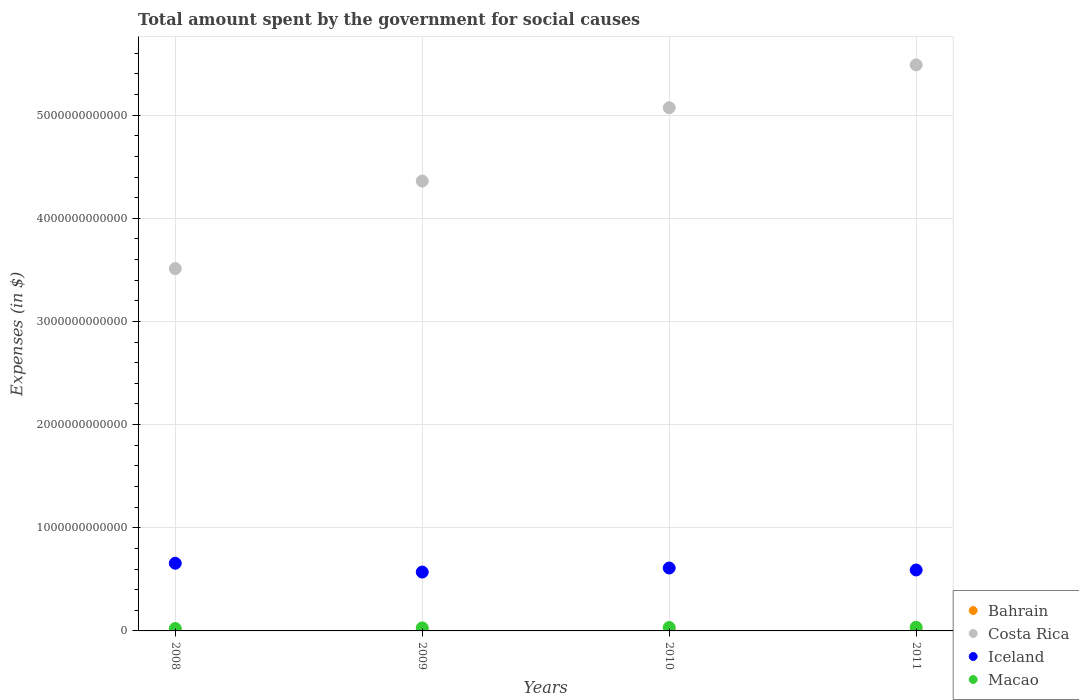What is the amount spent for social causes by the government in Costa Rica in 2008?
Provide a succinct answer. 3.51e+12. Across all years, what is the maximum amount spent for social causes by the government in Iceland?
Give a very brief answer. 6.56e+11. Across all years, what is the minimum amount spent for social causes by the government in Bahrain?
Provide a succinct answer. 1.57e+09. What is the total amount spent for social causes by the government in Macao in the graph?
Your answer should be compact. 1.21e+11. What is the difference between the amount spent for social causes by the government in Macao in 2009 and that in 2010?
Give a very brief answer. -3.84e+09. What is the difference between the amount spent for social causes by the government in Macao in 2010 and the amount spent for social causes by the government in Iceland in 2008?
Ensure brevity in your answer.  -6.23e+11. What is the average amount spent for social causes by the government in Bahrain per year?
Provide a short and direct response. 1.90e+09. In the year 2010, what is the difference between the amount spent for social causes by the government in Iceland and amount spent for social causes by the government in Bahrain?
Give a very brief answer. 6.08e+11. In how many years, is the amount spent for social causes by the government in Bahrain greater than 3800000000000 $?
Provide a succinct answer. 0. What is the ratio of the amount spent for social causes by the government in Bahrain in 2010 to that in 2011?
Your answer should be compact. 0.77. Is the amount spent for social causes by the government in Iceland in 2008 less than that in 2010?
Offer a very short reply. No. Is the difference between the amount spent for social causes by the government in Iceland in 2008 and 2009 greater than the difference between the amount spent for social causes by the government in Bahrain in 2008 and 2009?
Offer a very short reply. Yes. What is the difference between the highest and the second highest amount spent for social causes by the government in Macao?
Your answer should be very brief. 2.22e+09. What is the difference between the highest and the lowest amount spent for social causes by the government in Macao?
Your answer should be compact. 1.24e+1. In how many years, is the amount spent for social causes by the government in Iceland greater than the average amount spent for social causes by the government in Iceland taken over all years?
Your answer should be compact. 2. Is it the case that in every year, the sum of the amount spent for social causes by the government in Costa Rica and amount spent for social causes by the government in Bahrain  is greater than the sum of amount spent for social causes by the government in Iceland and amount spent for social causes by the government in Macao?
Provide a succinct answer. Yes. Is the amount spent for social causes by the government in Bahrain strictly greater than the amount spent for social causes by the government in Iceland over the years?
Provide a succinct answer. No. Is the amount spent for social causes by the government in Costa Rica strictly less than the amount spent for social causes by the government in Iceland over the years?
Give a very brief answer. No. How many dotlines are there?
Provide a short and direct response. 4. What is the difference between two consecutive major ticks on the Y-axis?
Offer a terse response. 1.00e+12. Does the graph contain grids?
Provide a short and direct response. Yes. Where does the legend appear in the graph?
Offer a very short reply. Bottom right. How are the legend labels stacked?
Provide a short and direct response. Vertical. What is the title of the graph?
Provide a short and direct response. Total amount spent by the government for social causes. Does "European Union" appear as one of the legend labels in the graph?
Your answer should be compact. No. What is the label or title of the X-axis?
Your answer should be very brief. Years. What is the label or title of the Y-axis?
Your answer should be very brief. Expenses (in $). What is the Expenses (in $) of Bahrain in 2008?
Provide a succinct answer. 1.57e+09. What is the Expenses (in $) in Costa Rica in 2008?
Your answer should be very brief. 3.51e+12. What is the Expenses (in $) in Iceland in 2008?
Your answer should be very brief. 6.56e+11. What is the Expenses (in $) of Macao in 2008?
Offer a terse response. 2.31e+1. What is the Expenses (in $) in Bahrain in 2009?
Your answer should be compact. 1.70e+09. What is the Expenses (in $) in Costa Rica in 2009?
Keep it short and to the point. 4.36e+12. What is the Expenses (in $) of Iceland in 2009?
Your response must be concise. 5.71e+11. What is the Expenses (in $) of Macao in 2009?
Your answer should be compact. 2.94e+1. What is the Expenses (in $) of Bahrain in 2010?
Ensure brevity in your answer.  1.88e+09. What is the Expenses (in $) in Costa Rica in 2010?
Provide a succinct answer. 5.07e+12. What is the Expenses (in $) of Iceland in 2010?
Your answer should be compact. 6.10e+11. What is the Expenses (in $) in Macao in 2010?
Your answer should be compact. 3.32e+1. What is the Expenses (in $) in Bahrain in 2011?
Your response must be concise. 2.43e+09. What is the Expenses (in $) of Costa Rica in 2011?
Keep it short and to the point. 5.49e+12. What is the Expenses (in $) of Iceland in 2011?
Give a very brief answer. 5.91e+11. What is the Expenses (in $) in Macao in 2011?
Make the answer very short. 3.55e+1. Across all years, what is the maximum Expenses (in $) in Bahrain?
Provide a short and direct response. 2.43e+09. Across all years, what is the maximum Expenses (in $) of Costa Rica?
Give a very brief answer. 5.49e+12. Across all years, what is the maximum Expenses (in $) in Iceland?
Offer a terse response. 6.56e+11. Across all years, what is the maximum Expenses (in $) in Macao?
Make the answer very short. 3.55e+1. Across all years, what is the minimum Expenses (in $) in Bahrain?
Offer a very short reply. 1.57e+09. Across all years, what is the minimum Expenses (in $) of Costa Rica?
Provide a short and direct response. 3.51e+12. Across all years, what is the minimum Expenses (in $) of Iceland?
Offer a terse response. 5.71e+11. Across all years, what is the minimum Expenses (in $) in Macao?
Ensure brevity in your answer.  2.31e+1. What is the total Expenses (in $) in Bahrain in the graph?
Your answer should be very brief. 7.59e+09. What is the total Expenses (in $) of Costa Rica in the graph?
Offer a terse response. 1.84e+13. What is the total Expenses (in $) in Iceland in the graph?
Offer a very short reply. 2.43e+12. What is the total Expenses (in $) of Macao in the graph?
Give a very brief answer. 1.21e+11. What is the difference between the Expenses (in $) of Bahrain in 2008 and that in 2009?
Offer a very short reply. -1.37e+08. What is the difference between the Expenses (in $) of Costa Rica in 2008 and that in 2009?
Your response must be concise. -8.49e+11. What is the difference between the Expenses (in $) in Iceland in 2008 and that in 2009?
Offer a very short reply. 8.54e+1. What is the difference between the Expenses (in $) in Macao in 2008 and that in 2009?
Ensure brevity in your answer.  -6.32e+09. What is the difference between the Expenses (in $) in Bahrain in 2008 and that in 2010?
Provide a short and direct response. -3.14e+08. What is the difference between the Expenses (in $) of Costa Rica in 2008 and that in 2010?
Offer a terse response. -1.56e+12. What is the difference between the Expenses (in $) of Iceland in 2008 and that in 2010?
Keep it short and to the point. 4.62e+1. What is the difference between the Expenses (in $) of Macao in 2008 and that in 2010?
Give a very brief answer. -1.02e+1. What is the difference between the Expenses (in $) in Bahrain in 2008 and that in 2011?
Your answer should be very brief. -8.67e+08. What is the difference between the Expenses (in $) of Costa Rica in 2008 and that in 2011?
Provide a succinct answer. -1.98e+12. What is the difference between the Expenses (in $) of Iceland in 2008 and that in 2011?
Keep it short and to the point. 6.54e+1. What is the difference between the Expenses (in $) in Macao in 2008 and that in 2011?
Your answer should be very brief. -1.24e+1. What is the difference between the Expenses (in $) of Bahrain in 2009 and that in 2010?
Keep it short and to the point. -1.78e+08. What is the difference between the Expenses (in $) in Costa Rica in 2009 and that in 2010?
Make the answer very short. -7.10e+11. What is the difference between the Expenses (in $) of Iceland in 2009 and that in 2010?
Make the answer very short. -3.92e+1. What is the difference between the Expenses (in $) of Macao in 2009 and that in 2010?
Offer a very short reply. -3.84e+09. What is the difference between the Expenses (in $) in Bahrain in 2009 and that in 2011?
Your response must be concise. -7.30e+08. What is the difference between the Expenses (in $) in Costa Rica in 2009 and that in 2011?
Offer a terse response. -1.13e+12. What is the difference between the Expenses (in $) in Iceland in 2009 and that in 2011?
Provide a succinct answer. -2.01e+1. What is the difference between the Expenses (in $) in Macao in 2009 and that in 2011?
Your response must be concise. -6.06e+09. What is the difference between the Expenses (in $) of Bahrain in 2010 and that in 2011?
Your response must be concise. -5.53e+08. What is the difference between the Expenses (in $) in Costa Rica in 2010 and that in 2011?
Your answer should be compact. -4.16e+11. What is the difference between the Expenses (in $) in Iceland in 2010 and that in 2011?
Ensure brevity in your answer.  1.92e+1. What is the difference between the Expenses (in $) of Macao in 2010 and that in 2011?
Offer a very short reply. -2.22e+09. What is the difference between the Expenses (in $) of Bahrain in 2008 and the Expenses (in $) of Costa Rica in 2009?
Provide a succinct answer. -4.36e+12. What is the difference between the Expenses (in $) in Bahrain in 2008 and the Expenses (in $) in Iceland in 2009?
Your response must be concise. -5.69e+11. What is the difference between the Expenses (in $) of Bahrain in 2008 and the Expenses (in $) of Macao in 2009?
Offer a very short reply. -2.78e+1. What is the difference between the Expenses (in $) in Costa Rica in 2008 and the Expenses (in $) in Iceland in 2009?
Offer a very short reply. 2.94e+12. What is the difference between the Expenses (in $) of Costa Rica in 2008 and the Expenses (in $) of Macao in 2009?
Keep it short and to the point. 3.48e+12. What is the difference between the Expenses (in $) in Iceland in 2008 and the Expenses (in $) in Macao in 2009?
Your answer should be very brief. 6.27e+11. What is the difference between the Expenses (in $) in Bahrain in 2008 and the Expenses (in $) in Costa Rica in 2010?
Give a very brief answer. -5.07e+12. What is the difference between the Expenses (in $) of Bahrain in 2008 and the Expenses (in $) of Iceland in 2010?
Offer a terse response. -6.08e+11. What is the difference between the Expenses (in $) of Bahrain in 2008 and the Expenses (in $) of Macao in 2010?
Your answer should be very brief. -3.17e+1. What is the difference between the Expenses (in $) in Costa Rica in 2008 and the Expenses (in $) in Iceland in 2010?
Your response must be concise. 2.90e+12. What is the difference between the Expenses (in $) of Costa Rica in 2008 and the Expenses (in $) of Macao in 2010?
Provide a short and direct response. 3.48e+12. What is the difference between the Expenses (in $) of Iceland in 2008 and the Expenses (in $) of Macao in 2010?
Your answer should be compact. 6.23e+11. What is the difference between the Expenses (in $) in Bahrain in 2008 and the Expenses (in $) in Costa Rica in 2011?
Your answer should be compact. -5.49e+12. What is the difference between the Expenses (in $) in Bahrain in 2008 and the Expenses (in $) in Iceland in 2011?
Provide a short and direct response. -5.89e+11. What is the difference between the Expenses (in $) of Bahrain in 2008 and the Expenses (in $) of Macao in 2011?
Your response must be concise. -3.39e+1. What is the difference between the Expenses (in $) of Costa Rica in 2008 and the Expenses (in $) of Iceland in 2011?
Offer a very short reply. 2.92e+12. What is the difference between the Expenses (in $) of Costa Rica in 2008 and the Expenses (in $) of Macao in 2011?
Your answer should be compact. 3.48e+12. What is the difference between the Expenses (in $) of Iceland in 2008 and the Expenses (in $) of Macao in 2011?
Your response must be concise. 6.21e+11. What is the difference between the Expenses (in $) of Bahrain in 2009 and the Expenses (in $) of Costa Rica in 2010?
Your response must be concise. -5.07e+12. What is the difference between the Expenses (in $) of Bahrain in 2009 and the Expenses (in $) of Iceland in 2010?
Ensure brevity in your answer.  -6.08e+11. What is the difference between the Expenses (in $) in Bahrain in 2009 and the Expenses (in $) in Macao in 2010?
Your answer should be compact. -3.15e+1. What is the difference between the Expenses (in $) in Costa Rica in 2009 and the Expenses (in $) in Iceland in 2010?
Offer a terse response. 3.75e+12. What is the difference between the Expenses (in $) of Costa Rica in 2009 and the Expenses (in $) of Macao in 2010?
Your answer should be compact. 4.33e+12. What is the difference between the Expenses (in $) of Iceland in 2009 and the Expenses (in $) of Macao in 2010?
Give a very brief answer. 5.37e+11. What is the difference between the Expenses (in $) of Bahrain in 2009 and the Expenses (in $) of Costa Rica in 2011?
Give a very brief answer. -5.49e+12. What is the difference between the Expenses (in $) in Bahrain in 2009 and the Expenses (in $) in Iceland in 2011?
Give a very brief answer. -5.89e+11. What is the difference between the Expenses (in $) of Bahrain in 2009 and the Expenses (in $) of Macao in 2011?
Provide a succinct answer. -3.37e+1. What is the difference between the Expenses (in $) of Costa Rica in 2009 and the Expenses (in $) of Iceland in 2011?
Keep it short and to the point. 3.77e+12. What is the difference between the Expenses (in $) of Costa Rica in 2009 and the Expenses (in $) of Macao in 2011?
Your answer should be compact. 4.33e+12. What is the difference between the Expenses (in $) in Iceland in 2009 and the Expenses (in $) in Macao in 2011?
Your answer should be very brief. 5.35e+11. What is the difference between the Expenses (in $) in Bahrain in 2010 and the Expenses (in $) in Costa Rica in 2011?
Ensure brevity in your answer.  -5.49e+12. What is the difference between the Expenses (in $) in Bahrain in 2010 and the Expenses (in $) in Iceland in 2011?
Give a very brief answer. -5.89e+11. What is the difference between the Expenses (in $) of Bahrain in 2010 and the Expenses (in $) of Macao in 2011?
Keep it short and to the point. -3.36e+1. What is the difference between the Expenses (in $) in Costa Rica in 2010 and the Expenses (in $) in Iceland in 2011?
Ensure brevity in your answer.  4.48e+12. What is the difference between the Expenses (in $) of Costa Rica in 2010 and the Expenses (in $) of Macao in 2011?
Offer a terse response. 5.04e+12. What is the difference between the Expenses (in $) in Iceland in 2010 and the Expenses (in $) in Macao in 2011?
Ensure brevity in your answer.  5.74e+11. What is the average Expenses (in $) in Bahrain per year?
Your answer should be very brief. 1.90e+09. What is the average Expenses (in $) of Costa Rica per year?
Make the answer very short. 4.61e+12. What is the average Expenses (in $) of Iceland per year?
Offer a terse response. 6.07e+11. What is the average Expenses (in $) of Macao per year?
Give a very brief answer. 3.03e+1. In the year 2008, what is the difference between the Expenses (in $) of Bahrain and Expenses (in $) of Costa Rica?
Provide a short and direct response. -3.51e+12. In the year 2008, what is the difference between the Expenses (in $) of Bahrain and Expenses (in $) of Iceland?
Your answer should be compact. -6.55e+11. In the year 2008, what is the difference between the Expenses (in $) of Bahrain and Expenses (in $) of Macao?
Give a very brief answer. -2.15e+1. In the year 2008, what is the difference between the Expenses (in $) of Costa Rica and Expenses (in $) of Iceland?
Ensure brevity in your answer.  2.86e+12. In the year 2008, what is the difference between the Expenses (in $) of Costa Rica and Expenses (in $) of Macao?
Make the answer very short. 3.49e+12. In the year 2008, what is the difference between the Expenses (in $) of Iceland and Expenses (in $) of Macao?
Offer a terse response. 6.33e+11. In the year 2009, what is the difference between the Expenses (in $) in Bahrain and Expenses (in $) in Costa Rica?
Keep it short and to the point. -4.36e+12. In the year 2009, what is the difference between the Expenses (in $) in Bahrain and Expenses (in $) in Iceland?
Offer a terse response. -5.69e+11. In the year 2009, what is the difference between the Expenses (in $) of Bahrain and Expenses (in $) of Macao?
Your answer should be compact. -2.77e+1. In the year 2009, what is the difference between the Expenses (in $) in Costa Rica and Expenses (in $) in Iceland?
Your answer should be very brief. 3.79e+12. In the year 2009, what is the difference between the Expenses (in $) in Costa Rica and Expenses (in $) in Macao?
Your answer should be compact. 4.33e+12. In the year 2009, what is the difference between the Expenses (in $) of Iceland and Expenses (in $) of Macao?
Keep it short and to the point. 5.41e+11. In the year 2010, what is the difference between the Expenses (in $) in Bahrain and Expenses (in $) in Costa Rica?
Keep it short and to the point. -5.07e+12. In the year 2010, what is the difference between the Expenses (in $) of Bahrain and Expenses (in $) of Iceland?
Offer a terse response. -6.08e+11. In the year 2010, what is the difference between the Expenses (in $) in Bahrain and Expenses (in $) in Macao?
Your answer should be compact. -3.13e+1. In the year 2010, what is the difference between the Expenses (in $) of Costa Rica and Expenses (in $) of Iceland?
Your answer should be compact. 4.46e+12. In the year 2010, what is the difference between the Expenses (in $) in Costa Rica and Expenses (in $) in Macao?
Offer a very short reply. 5.04e+12. In the year 2010, what is the difference between the Expenses (in $) of Iceland and Expenses (in $) of Macao?
Provide a succinct answer. 5.77e+11. In the year 2011, what is the difference between the Expenses (in $) in Bahrain and Expenses (in $) in Costa Rica?
Keep it short and to the point. -5.49e+12. In the year 2011, what is the difference between the Expenses (in $) in Bahrain and Expenses (in $) in Iceland?
Ensure brevity in your answer.  -5.88e+11. In the year 2011, what is the difference between the Expenses (in $) in Bahrain and Expenses (in $) in Macao?
Make the answer very short. -3.30e+1. In the year 2011, what is the difference between the Expenses (in $) of Costa Rica and Expenses (in $) of Iceland?
Keep it short and to the point. 4.90e+12. In the year 2011, what is the difference between the Expenses (in $) in Costa Rica and Expenses (in $) in Macao?
Provide a short and direct response. 5.45e+12. In the year 2011, what is the difference between the Expenses (in $) of Iceland and Expenses (in $) of Macao?
Offer a terse response. 5.55e+11. What is the ratio of the Expenses (in $) in Bahrain in 2008 to that in 2009?
Give a very brief answer. 0.92. What is the ratio of the Expenses (in $) in Costa Rica in 2008 to that in 2009?
Provide a short and direct response. 0.81. What is the ratio of the Expenses (in $) in Iceland in 2008 to that in 2009?
Your response must be concise. 1.15. What is the ratio of the Expenses (in $) of Macao in 2008 to that in 2009?
Your answer should be very brief. 0.79. What is the ratio of the Expenses (in $) in Bahrain in 2008 to that in 2010?
Your answer should be compact. 0.83. What is the ratio of the Expenses (in $) of Costa Rica in 2008 to that in 2010?
Give a very brief answer. 0.69. What is the ratio of the Expenses (in $) of Iceland in 2008 to that in 2010?
Your response must be concise. 1.08. What is the ratio of the Expenses (in $) of Macao in 2008 to that in 2010?
Offer a very short reply. 0.69. What is the ratio of the Expenses (in $) of Bahrain in 2008 to that in 2011?
Offer a terse response. 0.64. What is the ratio of the Expenses (in $) of Costa Rica in 2008 to that in 2011?
Provide a short and direct response. 0.64. What is the ratio of the Expenses (in $) in Iceland in 2008 to that in 2011?
Provide a short and direct response. 1.11. What is the ratio of the Expenses (in $) in Macao in 2008 to that in 2011?
Offer a very short reply. 0.65. What is the ratio of the Expenses (in $) of Bahrain in 2009 to that in 2010?
Provide a succinct answer. 0.91. What is the ratio of the Expenses (in $) in Costa Rica in 2009 to that in 2010?
Offer a terse response. 0.86. What is the ratio of the Expenses (in $) in Iceland in 2009 to that in 2010?
Provide a succinct answer. 0.94. What is the ratio of the Expenses (in $) in Macao in 2009 to that in 2010?
Make the answer very short. 0.88. What is the ratio of the Expenses (in $) in Bahrain in 2009 to that in 2011?
Offer a very short reply. 0.7. What is the ratio of the Expenses (in $) in Costa Rica in 2009 to that in 2011?
Offer a very short reply. 0.79. What is the ratio of the Expenses (in $) of Iceland in 2009 to that in 2011?
Your answer should be compact. 0.97. What is the ratio of the Expenses (in $) of Macao in 2009 to that in 2011?
Provide a short and direct response. 0.83. What is the ratio of the Expenses (in $) of Bahrain in 2010 to that in 2011?
Provide a short and direct response. 0.77. What is the ratio of the Expenses (in $) in Costa Rica in 2010 to that in 2011?
Your response must be concise. 0.92. What is the ratio of the Expenses (in $) of Iceland in 2010 to that in 2011?
Offer a very short reply. 1.03. What is the ratio of the Expenses (in $) of Macao in 2010 to that in 2011?
Ensure brevity in your answer.  0.94. What is the difference between the highest and the second highest Expenses (in $) in Bahrain?
Your answer should be very brief. 5.53e+08. What is the difference between the highest and the second highest Expenses (in $) in Costa Rica?
Keep it short and to the point. 4.16e+11. What is the difference between the highest and the second highest Expenses (in $) of Iceland?
Ensure brevity in your answer.  4.62e+1. What is the difference between the highest and the second highest Expenses (in $) in Macao?
Your response must be concise. 2.22e+09. What is the difference between the highest and the lowest Expenses (in $) in Bahrain?
Keep it short and to the point. 8.67e+08. What is the difference between the highest and the lowest Expenses (in $) of Costa Rica?
Give a very brief answer. 1.98e+12. What is the difference between the highest and the lowest Expenses (in $) of Iceland?
Provide a short and direct response. 8.54e+1. What is the difference between the highest and the lowest Expenses (in $) in Macao?
Keep it short and to the point. 1.24e+1. 